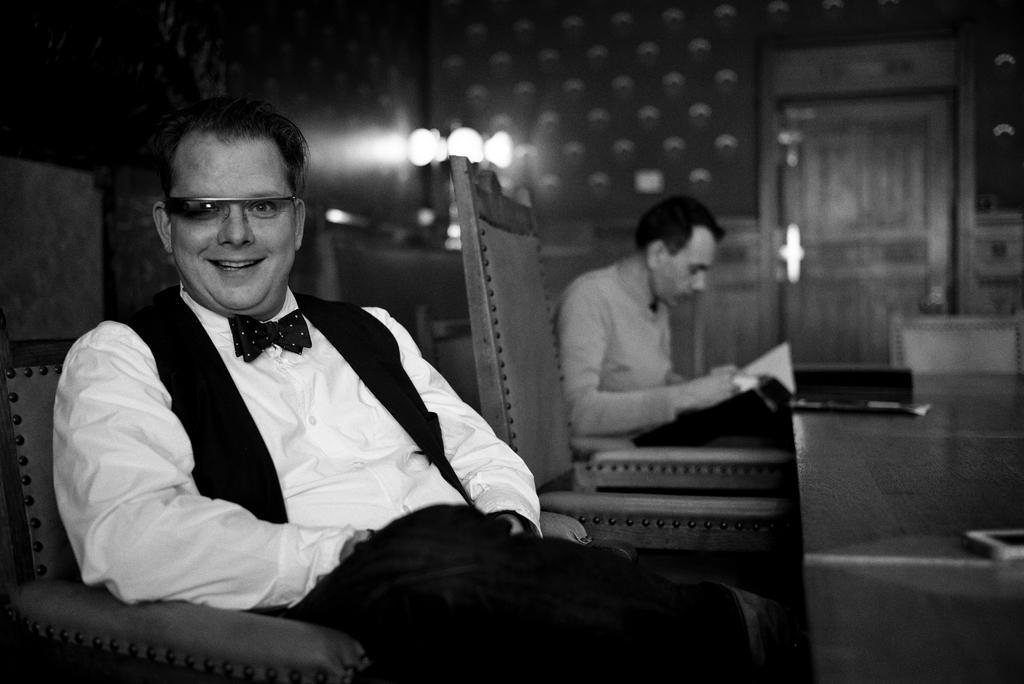Can you describe this image briefly? These people are sitting on chairs. On this table there is a mobile and things. Front this person is smiling and wore goggles. Background it is blur. We can see a wall, lights and door. Another person is looking into an open book. 